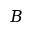<formula> <loc_0><loc_0><loc_500><loc_500>B</formula> 